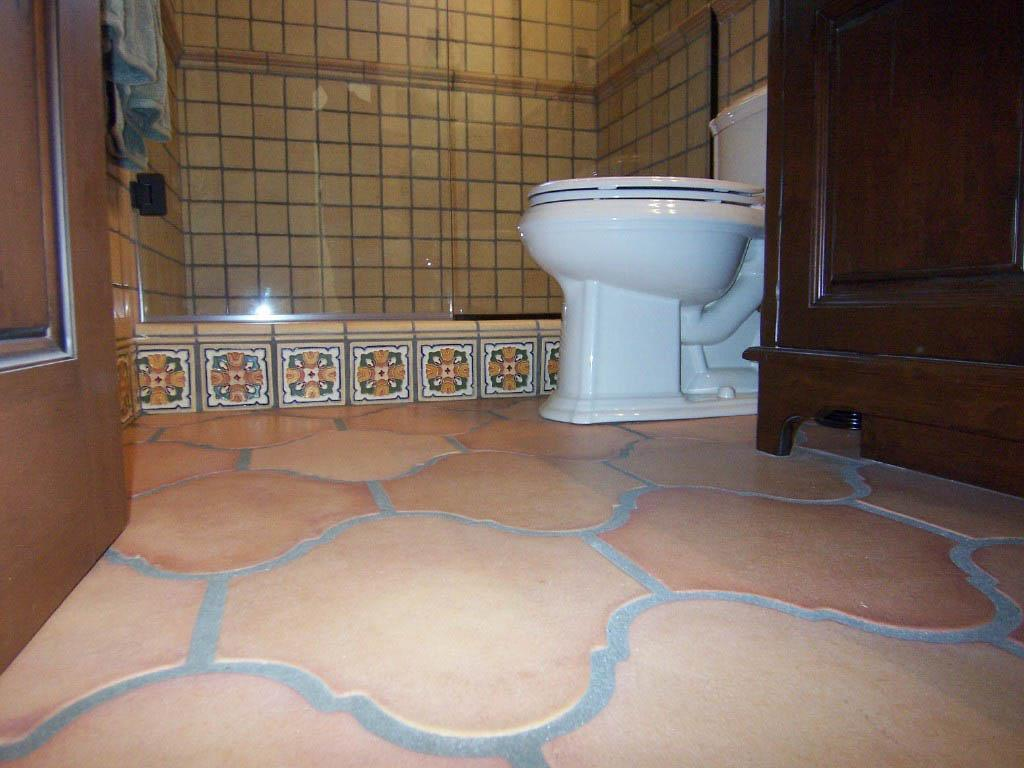What type of toilet is visible in the image? There is a white color toilet in the image. What can be seen hanging near the toilet? There is a towel in the image. What is the background of the image made of? There is a wall in the image. Is there a way to enter or exit the room in the image? Yes, there is a door in the image. What type of storage furniture is present in the image? There is a cupboard in the image. What is the color of the floor in the image? The floor is in brown and ash color. What type of trucks are parked outside the room in the image? There are no trucks visible in the image; it only shows a toilet, towel, wall, door, cupboard, and floor. How many eggs are present on the cupboard in the image? There are no eggs present in the image; it only shows a toilet, towel, wall, door, cupboard, and floor. 